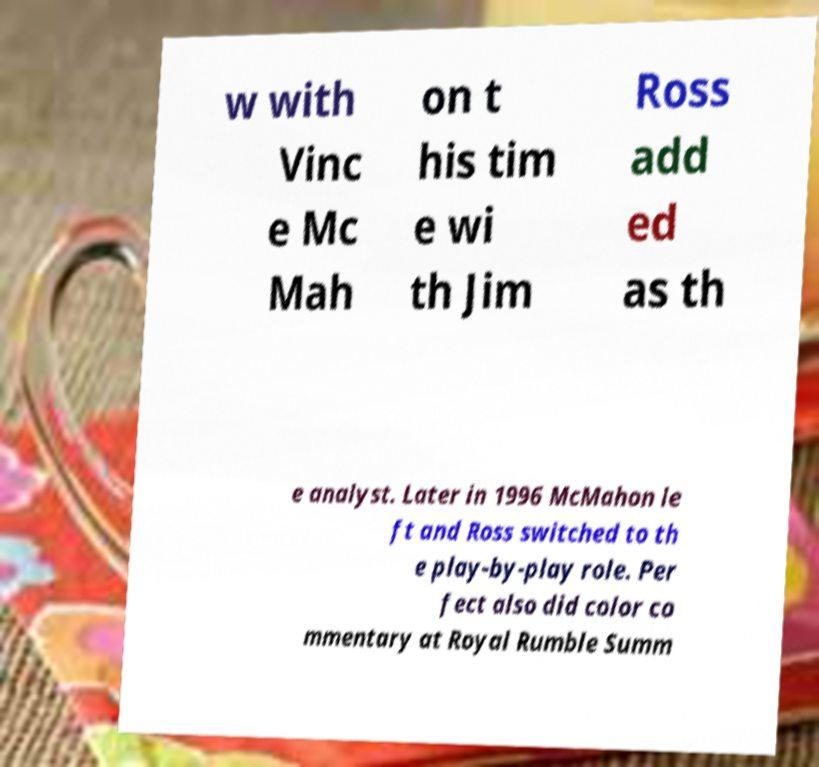What messages or text are displayed in this image? I need them in a readable, typed format. w with Vinc e Mc Mah on t his tim e wi th Jim Ross add ed as th e analyst. Later in 1996 McMahon le ft and Ross switched to th e play-by-play role. Per fect also did color co mmentary at Royal Rumble Summ 